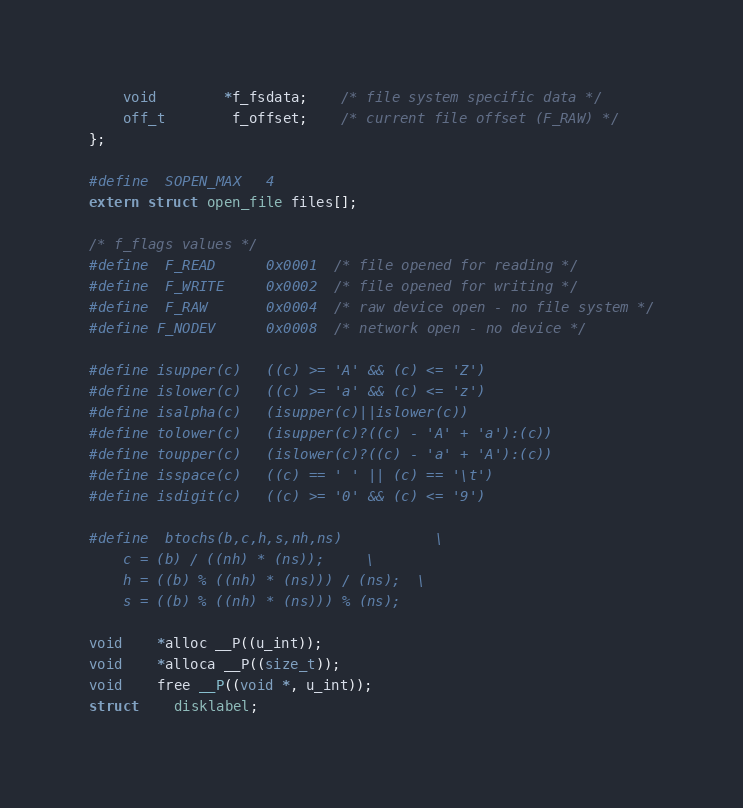Convert code to text. <code><loc_0><loc_0><loc_500><loc_500><_C_>	void		*f_fsdata;	/* file system specific data */
	off_t		f_offset;	/* current file offset (F_RAW) */
};

#define	SOPEN_MAX	4
extern struct open_file files[];

/* f_flags values */
#define	F_READ		0x0001	/* file opened for reading */
#define	F_WRITE		0x0002	/* file opened for writing */
#define	F_RAW		0x0004	/* raw device open - no file system */
#define F_NODEV		0x0008	/* network open - no device */

#define isupper(c)	((c) >= 'A' && (c) <= 'Z')
#define islower(c)	((c) >= 'a' && (c) <= 'z')
#define isalpha(c)	(isupper(c)||islower(c))
#define tolower(c)	(isupper(c)?((c) - 'A' + 'a'):(c))
#define toupper(c)	(islower(c)?((c) - 'a' + 'A'):(c))
#define isspace(c)	((c) == ' ' || (c) == '\t')
#define isdigit(c)	((c) >= '0' && (c) <= '9')

#define	btochs(b,c,h,s,nh,ns)			\
	c = (b) / ((nh) * (ns));		\
	h = ((b) % ((nh) * (ns))) / (ns);	\
	s = ((b) % ((nh) * (ns))) % (ns);

void	*alloc __P((u_int));
void	*alloca __P((size_t));
void	free __P((void *, u_int));
struct	disklabel;</code> 